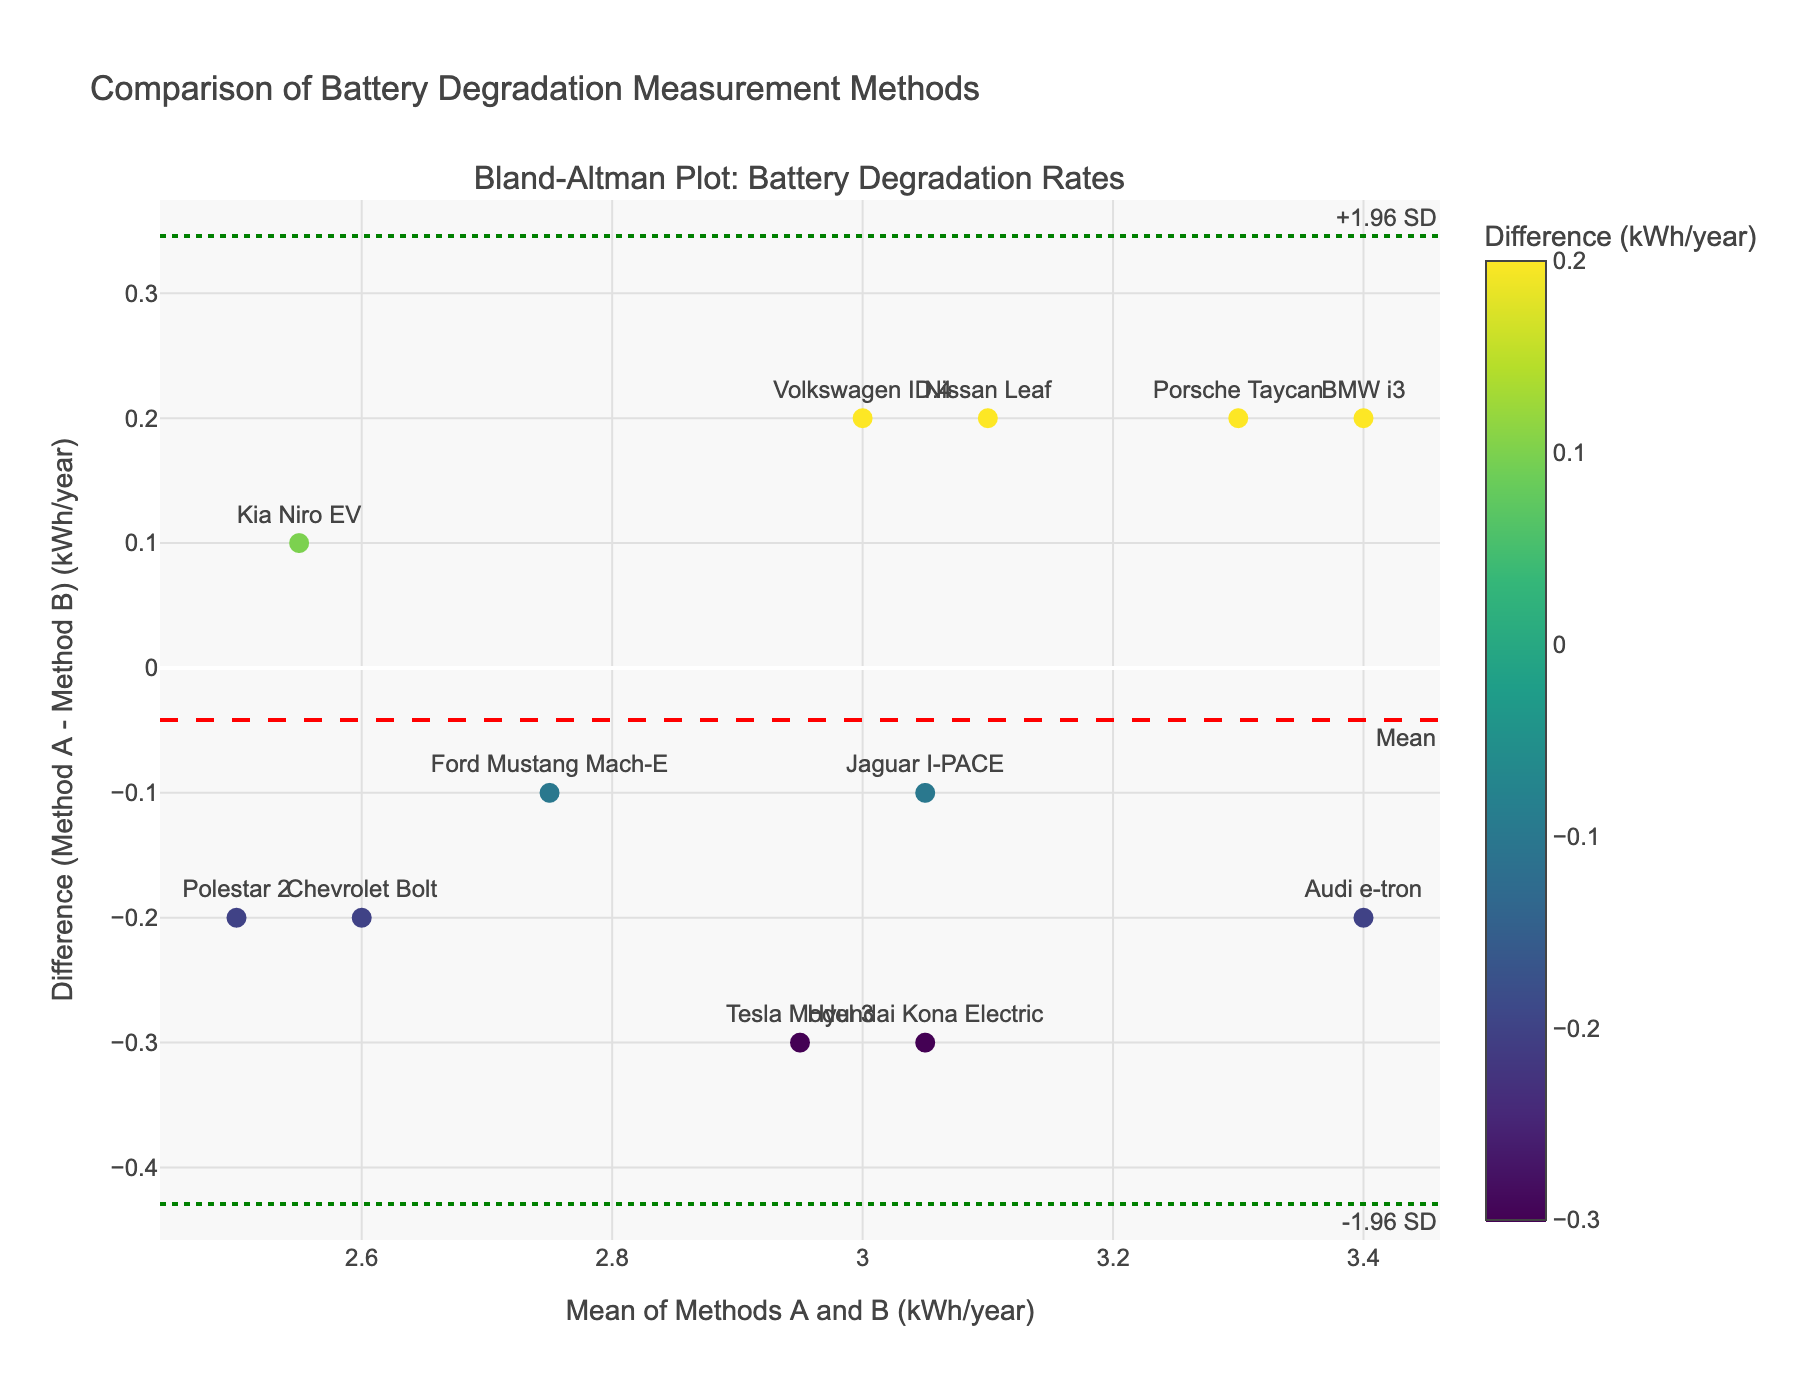What is the title of the plot? The title of the plot is displayed at the top of the figure. It reads "Comparison of Battery Degradation Measurement Methods."
Answer: Comparison of Battery Degradation Measurement Methods How many data points are plotted in the figure? There are 12 vehicle models, hence there are 12 data points plotted in the figure.
Answer: 12 What is the mean difference value, and how is it represented in the plot? The mean difference value is the average of the differences between Method A and Method B. This is represented as a red dashed horizontal line labeled "Mean."
Answer: Mean What are the values of the limits of agreement, and how are they represented in the plot? The lower limit of agreement is represented as a green dotted line labeled "-1.96 SD," and the upper limit of agreement is a green dotted line labeled "+1.96 SD." The values are shown as horizontal lines in the plot.
Answer: -1.96 SD and +1.96 SD Which vehicle model shows the maximum positive difference between Method A and Method B, and what is the value? The differences for each vehicle model are plotted on the y-axis. The Tesla Model 3 has the largest positive difference, approximately 0.3 kWh/year.
Answer: Tesla Model 3, 0.3 kWh/year What are the mean degradation rates for Tesla Model 3 and Porsche Taycan, and what are their corresponding differences? Tesla Model 3 has a mean value of 2.95 kWh/year with a difference of 0.3 kWh/year (3.1-2.8), and Porsche Taycan has a mean value of 3.3 kWh/year with a difference of 0.2 kWh/year (3.4-3.2).
Answer: Tesla Model 3: mean 2.95, difference 0.3; Porsche Taycan: mean 3.3, difference 0.2 Is the agreement between Method A and Method B consistent across all vehicle models? By observing the spread of the data points around the mean difference line, you can see variations, indicating that the agreement is not entirely consistent across all models.
Answer: No Which vehicle models have differences closest to zero, meaning almost no difference between Method A and Method B? The data points closest to the horizontal zero line indicate almost no difference. Chevrolet Bolt and Kia Niro EV have differences close to zero.
Answer: Chevrolet Bolt and Kia Niro EV Which vehicle models have differences that fall outside the limits of agreement, if any? Check if there are any data points outside the green dotted lines representing the limits of agreement; none of the vehicle models are outside these limits.
Answer: None 